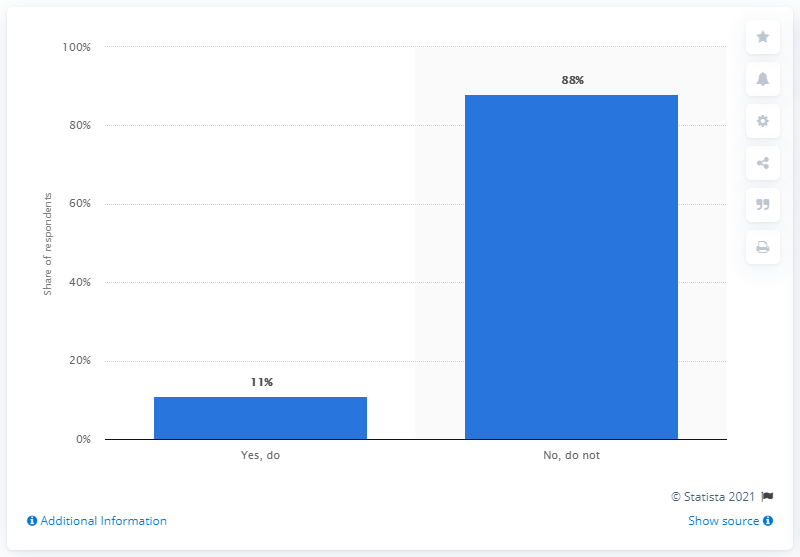Indicate a few pertinent items in this graphic. By how much percentage less do people smoke marijuana? 77% fewer people smoke marijuana compared to previous years. The largest value is 88% 